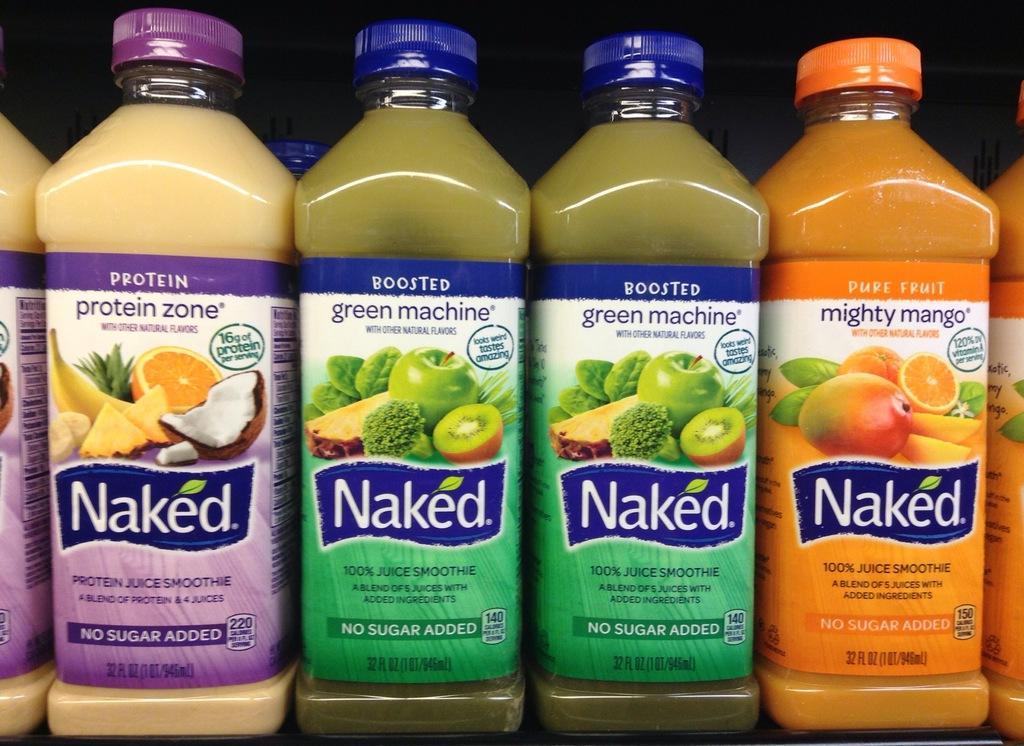Describe this image in one or two sentences. We can see group of bottles with different color caps and we can see stickers on these bottles. 